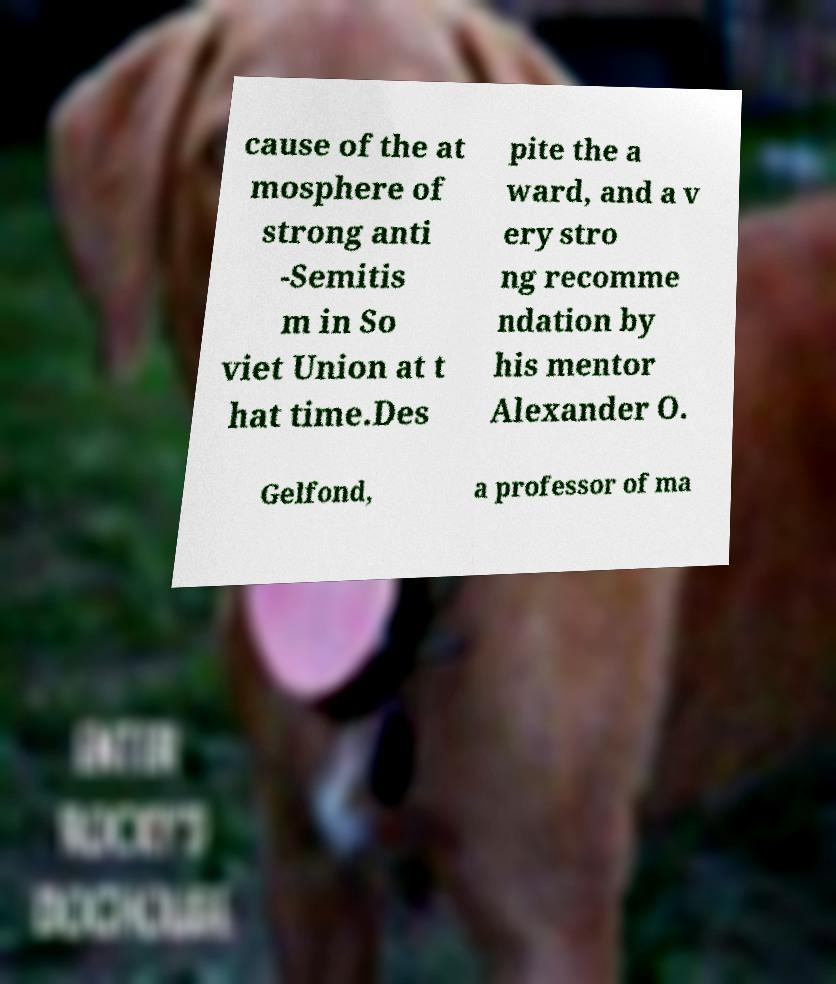For documentation purposes, I need the text within this image transcribed. Could you provide that? cause of the at mosphere of strong anti -Semitis m in So viet Union at t hat time.Des pite the a ward, and a v ery stro ng recomme ndation by his mentor Alexander O. Gelfond, a professor of ma 